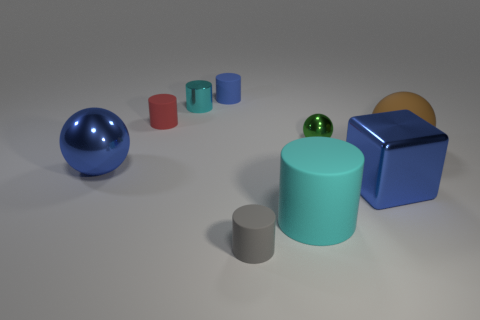There is a cylinder that is the same color as the metallic block; what material is it?
Ensure brevity in your answer.  Rubber. How many other rubber spheres are the same color as the matte ball?
Keep it short and to the point. 0. There is a tiny metallic thing that is behind the green thing; is it the same shape as the tiny gray rubber object?
Your answer should be compact. Yes. Is the number of small cyan shiny things behind the cyan metallic thing less than the number of small cylinders behind the small green shiny ball?
Offer a very short reply. Yes. What is the cyan cylinder in front of the metal block made of?
Give a very brief answer. Rubber. What is the size of the rubber thing that is the same color as the big metal block?
Offer a terse response. Small. Are there any other metal objects that have the same size as the cyan metallic thing?
Your answer should be compact. Yes. There is a cyan metallic thing; is it the same shape as the big rubber object that is in front of the shiny cube?
Offer a very short reply. Yes. There is a metallic block on the right side of the tiny green thing; is it the same size as the cyan object behind the matte ball?
Your answer should be very brief. No. How many other objects are there of the same shape as the tiny gray object?
Provide a succinct answer. 4. 